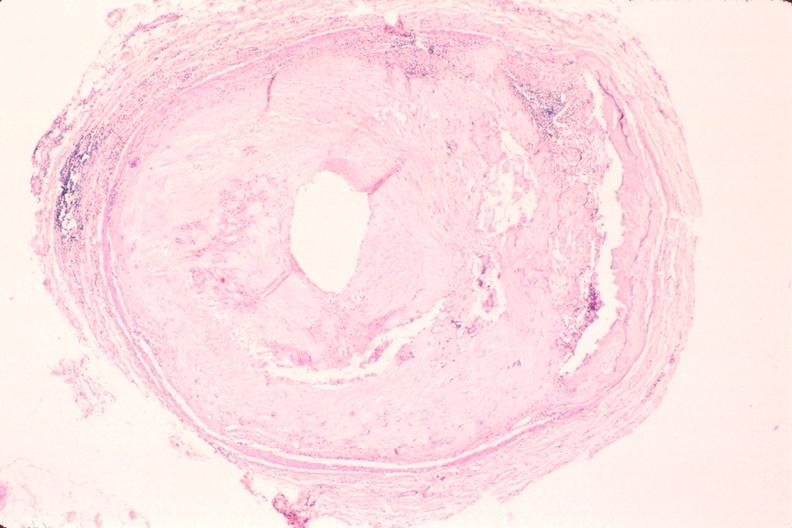s cardiovascular present?
Answer the question using a single word or phrase. Yes 